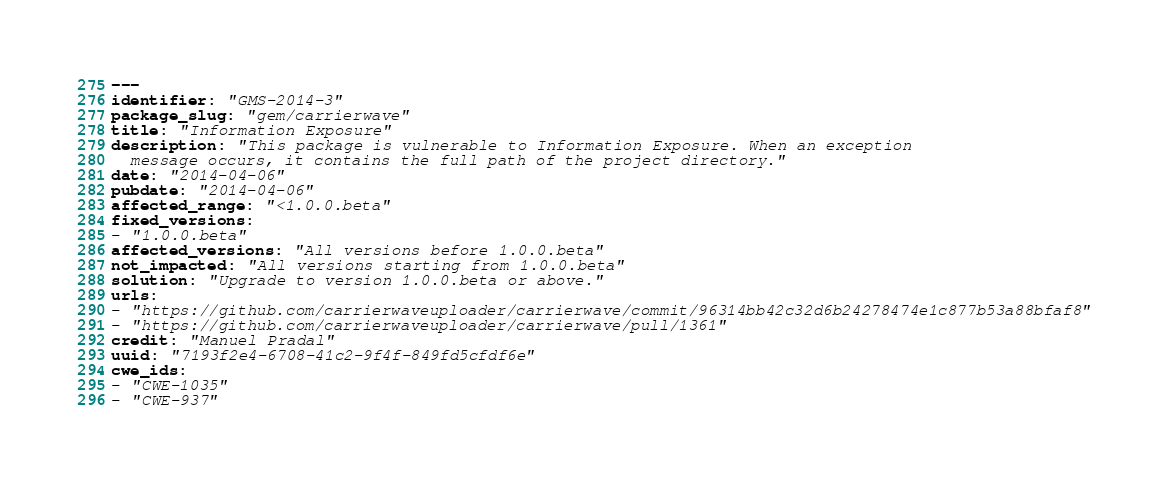Convert code to text. <code><loc_0><loc_0><loc_500><loc_500><_YAML_>---
identifier: "GMS-2014-3"
package_slug: "gem/carrierwave"
title: "Information Exposure"
description: "This package is vulnerable to Information Exposure. When an exception
  message occurs, it contains the full path of the project directory."
date: "2014-04-06"
pubdate: "2014-04-06"
affected_range: "<1.0.0.beta"
fixed_versions:
- "1.0.0.beta"
affected_versions: "All versions before 1.0.0.beta"
not_impacted: "All versions starting from 1.0.0.beta"
solution: "Upgrade to version 1.0.0.beta or above."
urls:
- "https://github.com/carrierwaveuploader/carrierwave/commit/96314bb42c32d6b24278474e1c877b53a88bfaf8"
- "https://github.com/carrierwaveuploader/carrierwave/pull/1361"
credit: "Manuel Pradal"
uuid: "7193f2e4-6708-41c2-9f4f-849fd5cfdf6e"
cwe_ids:
- "CWE-1035"
- "CWE-937"
</code> 